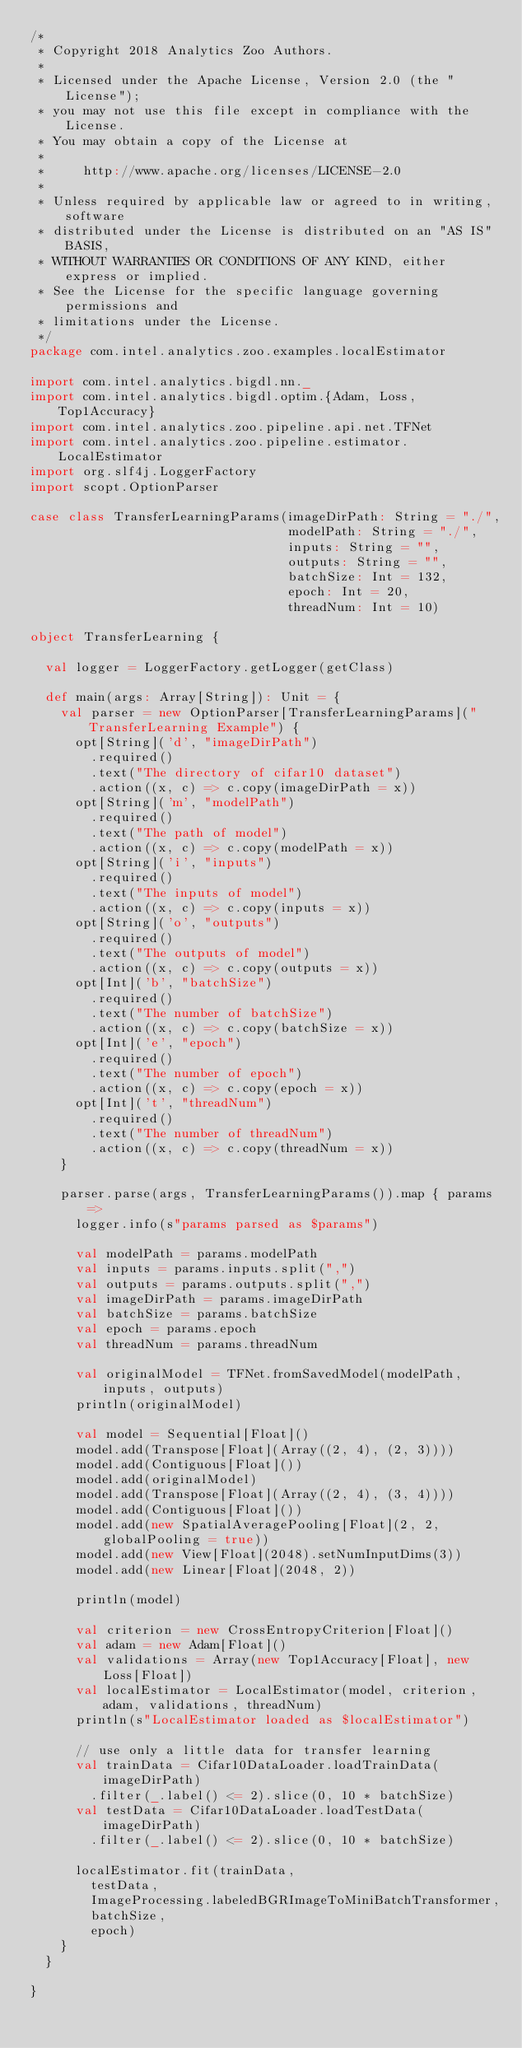Convert code to text. <code><loc_0><loc_0><loc_500><loc_500><_Scala_>/*
 * Copyright 2018 Analytics Zoo Authors.
 *
 * Licensed under the Apache License, Version 2.0 (the "License");
 * you may not use this file except in compliance with the License.
 * You may obtain a copy of the License at
 *
 *     http://www.apache.org/licenses/LICENSE-2.0
 *
 * Unless required by applicable law or agreed to in writing, software
 * distributed under the License is distributed on an "AS IS" BASIS,
 * WITHOUT WARRANTIES OR CONDITIONS OF ANY KIND, either express or implied.
 * See the License for the specific language governing permissions and
 * limitations under the License.
 */
package com.intel.analytics.zoo.examples.localEstimator

import com.intel.analytics.bigdl.nn._
import com.intel.analytics.bigdl.optim.{Adam, Loss, Top1Accuracy}
import com.intel.analytics.zoo.pipeline.api.net.TFNet
import com.intel.analytics.zoo.pipeline.estimator.LocalEstimator
import org.slf4j.LoggerFactory
import scopt.OptionParser

case class TransferLearningParams(imageDirPath: String = "./",
                                  modelPath: String = "./",
                                  inputs: String = "",
                                  outputs: String = "",
                                  batchSize: Int = 132,
                                  epoch: Int = 20,
                                  threadNum: Int = 10)

object TransferLearning {

  val logger = LoggerFactory.getLogger(getClass)

  def main(args: Array[String]): Unit = {
    val parser = new OptionParser[TransferLearningParams]("TransferLearning Example") {
      opt[String]('d', "imageDirPath")
        .required()
        .text("The directory of cifar10 dataset")
        .action((x, c) => c.copy(imageDirPath = x))
      opt[String]('m', "modelPath")
        .required()
        .text("The path of model")
        .action((x, c) => c.copy(modelPath = x))
      opt[String]('i', "inputs")
        .required()
        .text("The inputs of model")
        .action((x, c) => c.copy(inputs = x))
      opt[String]('o', "outputs")
        .required()
        .text("The outputs of model")
        .action((x, c) => c.copy(outputs = x))
      opt[Int]('b', "batchSize")
        .required()
        .text("The number of batchSize")
        .action((x, c) => c.copy(batchSize = x))
      opt[Int]('e', "epoch")
        .required()
        .text("The number of epoch")
        .action((x, c) => c.copy(epoch = x))
      opt[Int]('t', "threadNum")
        .required()
        .text("The number of threadNum")
        .action((x, c) => c.copy(threadNum = x))
    }

    parser.parse(args, TransferLearningParams()).map { params =>
      logger.info(s"params parsed as $params")

      val modelPath = params.modelPath
      val inputs = params.inputs.split(",")
      val outputs = params.outputs.split(",")
      val imageDirPath = params.imageDirPath
      val batchSize = params.batchSize
      val epoch = params.epoch
      val threadNum = params.threadNum

      val originalModel = TFNet.fromSavedModel(modelPath, inputs, outputs)
      println(originalModel)

      val model = Sequential[Float]()
      model.add(Transpose[Float](Array((2, 4), (2, 3))))
      model.add(Contiguous[Float]())
      model.add(originalModel)
      model.add(Transpose[Float](Array((2, 4), (3, 4))))
      model.add(Contiguous[Float]())
      model.add(new SpatialAveragePooling[Float](2, 2, globalPooling = true))
      model.add(new View[Float](2048).setNumInputDims(3))
      model.add(new Linear[Float](2048, 2))

      println(model)

      val criterion = new CrossEntropyCriterion[Float]()
      val adam = new Adam[Float]()
      val validations = Array(new Top1Accuracy[Float], new Loss[Float])
      val localEstimator = LocalEstimator(model, criterion, adam, validations, threadNum)
      println(s"LocalEstimator loaded as $localEstimator")

      // use only a little data for transfer learning
      val trainData = Cifar10DataLoader.loadTrainData(imageDirPath)
        .filter(_.label() <= 2).slice(0, 10 * batchSize)
      val testData = Cifar10DataLoader.loadTestData(imageDirPath)
        .filter(_.label() <= 2).slice(0, 10 * batchSize)

      localEstimator.fit(trainData,
        testData,
        ImageProcessing.labeledBGRImageToMiniBatchTransformer,
        batchSize,
        epoch)
    }
  }

}
</code> 